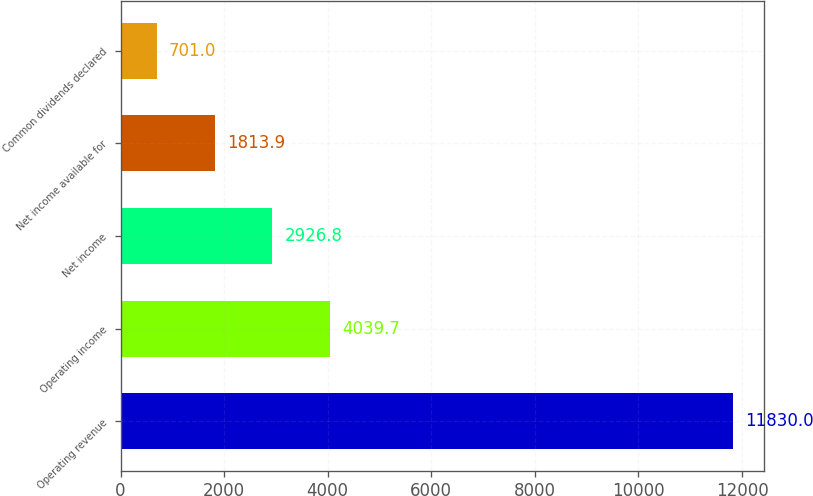Convert chart to OTSL. <chart><loc_0><loc_0><loc_500><loc_500><bar_chart><fcel>Operating revenue<fcel>Operating income<fcel>Net income<fcel>Net income available for<fcel>Common dividends declared<nl><fcel>11830<fcel>4039.7<fcel>2926.8<fcel>1813.9<fcel>701<nl></chart> 